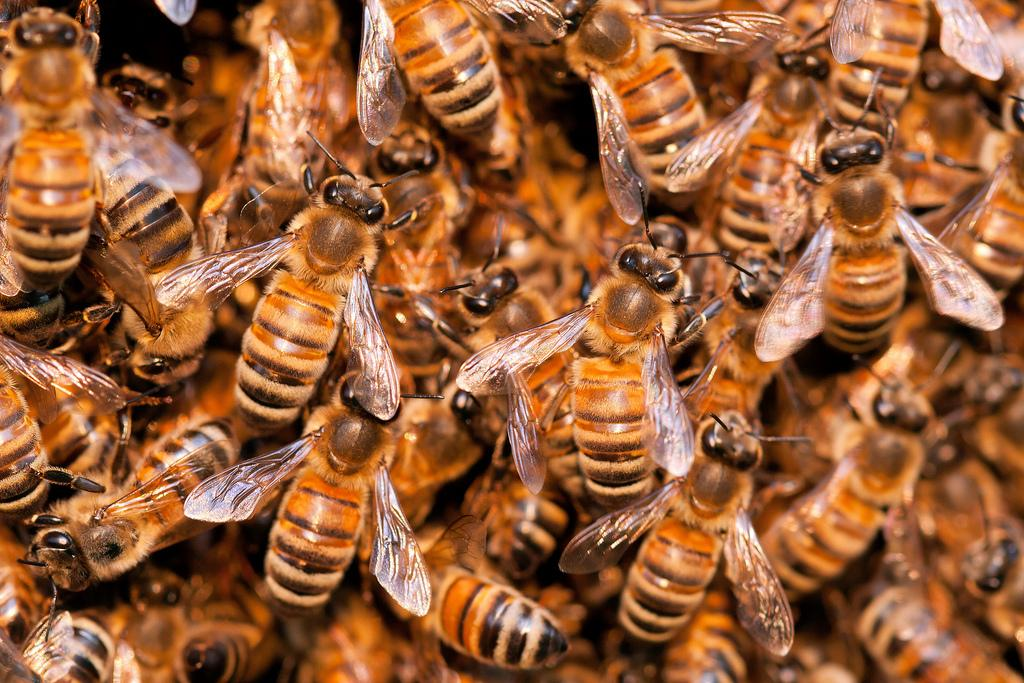What type of insects are present in the image? There is a colony of honey bees in the image. Can you describe the behavior or activity of the honey bees in the image? The provided facts do not specify the behavior or activity of the honey bees in the image. What type of bird can be seen interacting with the honey bees in the image? There is no bird present in the image; it features a colony of honey bees. What is the aftermath of the turkey's interaction with the honey bees in the image? There is no turkey present in the image, so there is no aftermath involving a turkey. 